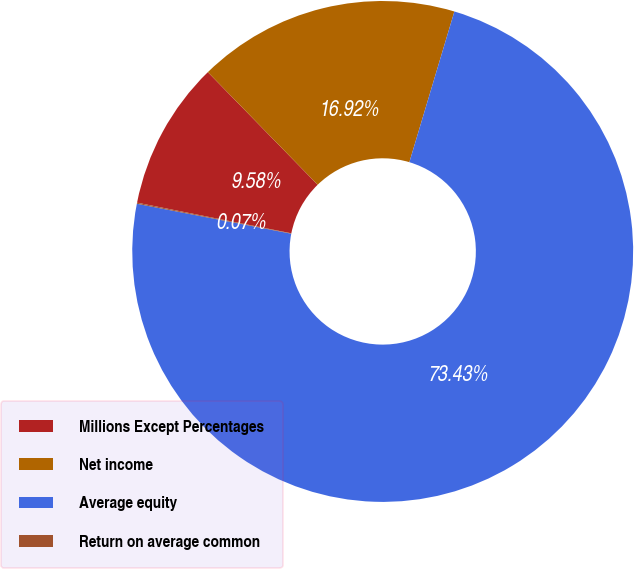<chart> <loc_0><loc_0><loc_500><loc_500><pie_chart><fcel>Millions Except Percentages<fcel>Net income<fcel>Average equity<fcel>Return on average common<nl><fcel>9.58%<fcel>16.92%<fcel>73.43%<fcel>0.07%<nl></chart> 